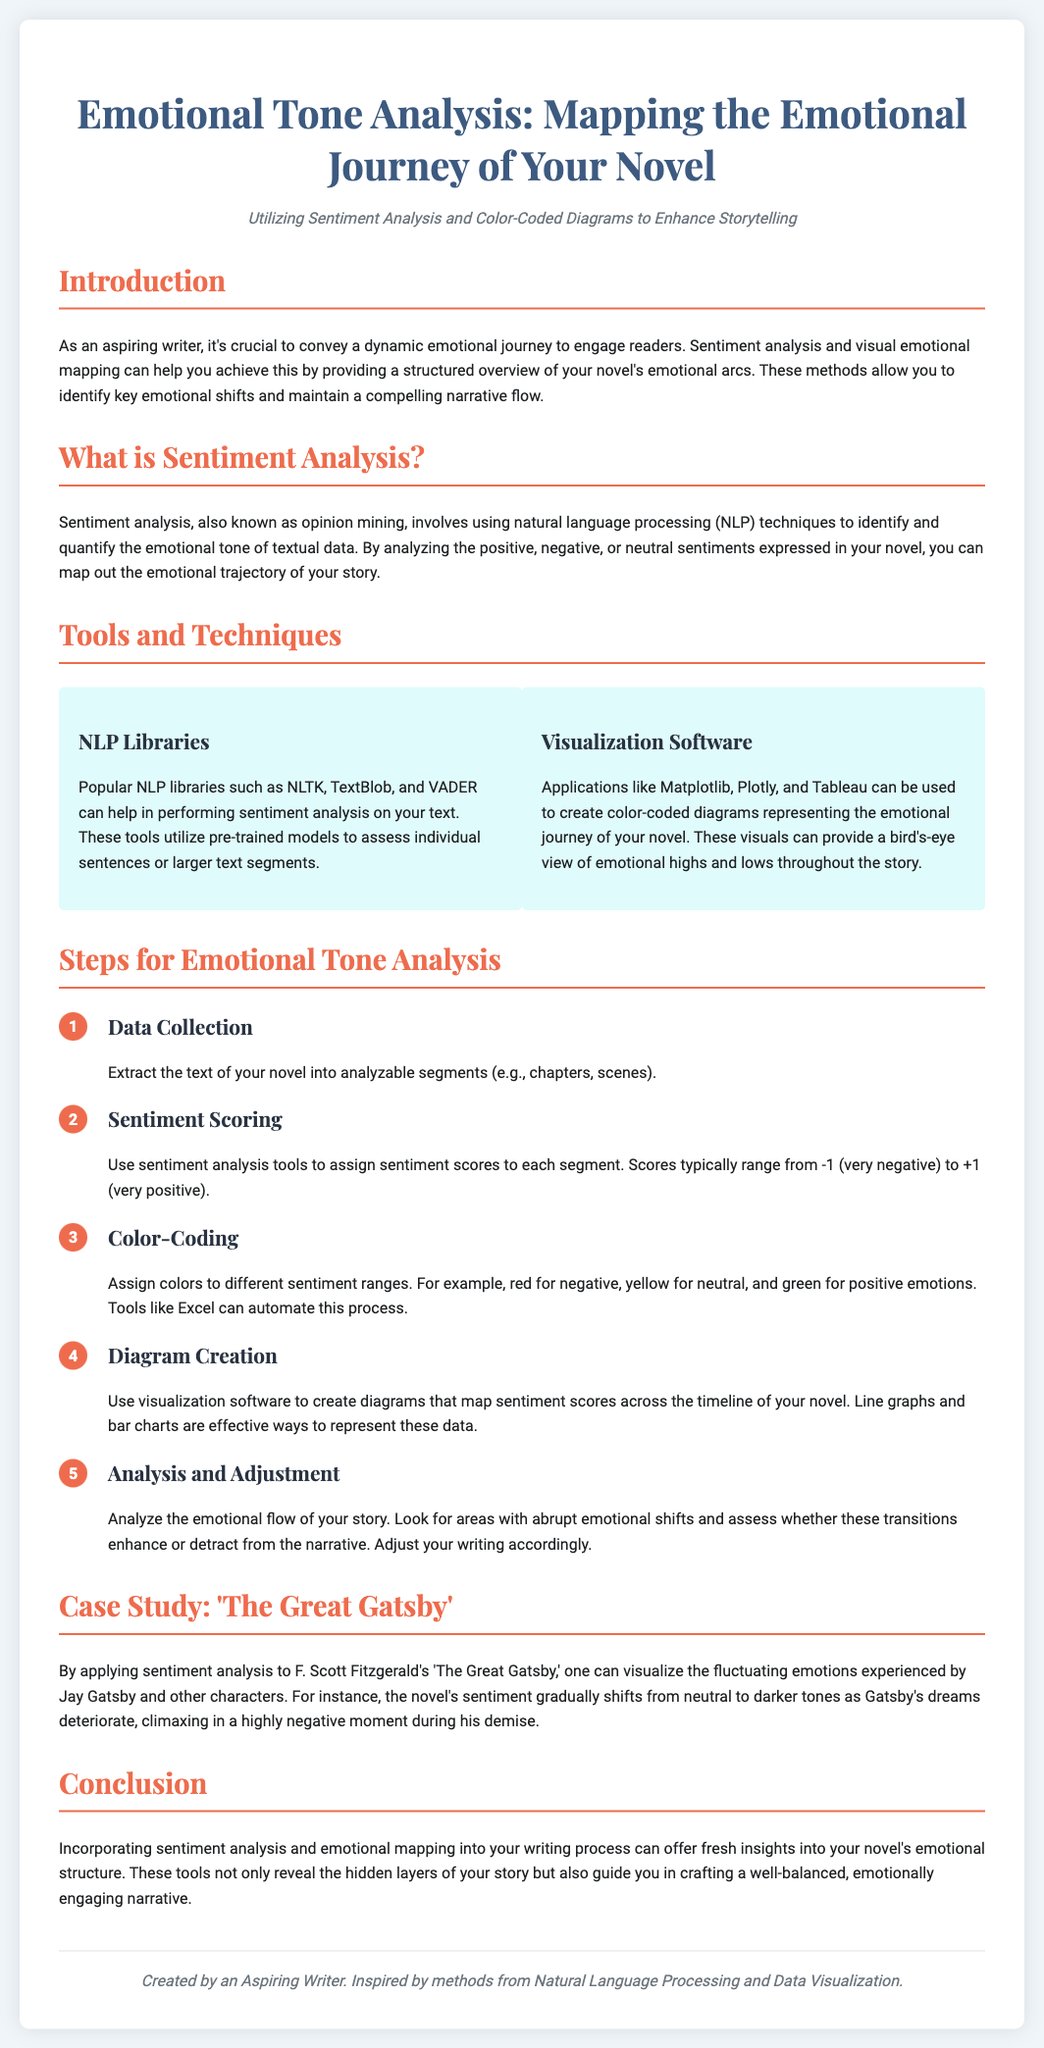What is the title of the poster? The title of the poster is stated at the top of the document.
Answer: Emotional Tone Analysis: Mapping the Emotional Journey of Your Novel What is the subtitle of the poster? The subtitle provides additional context for the poster's content.
Answer: Utilizing Sentiment Analysis and Color-Coded Diagrams to Enhance Storytelling Which famous novel is used as a case study? The case study highlights a well-known work to illustrate sentiment analysis.
Answer: The Great Gatsby What are the three main categories of sentiment as mentioned in the tools section? The tools section describes how sentiments are categorized for analysis.
Answer: Negative, Neutral, Positive What is the first step in the emotional tone analysis process? The steps give a sequential approach to emotional tone analysis.
Answer: Data Collection Which NLP library is mentioned in the document? The document lists NLP libraries that can be used for sentiment analysis.
Answer: NLTK What emotional tone is represented by the color red in the color-coding step? The color-coding provides a visual representation of emotional tones.
Answer: Negative What visualization tool can be used to create diagrams? The tools section suggests software for visualizing the emotional journey.
Answer: Tableau How do you assign scores in sentiment scoring? The sentiment scoring step describes the method of quantifying emotions.
Answer: Ranges from -1 to +1 